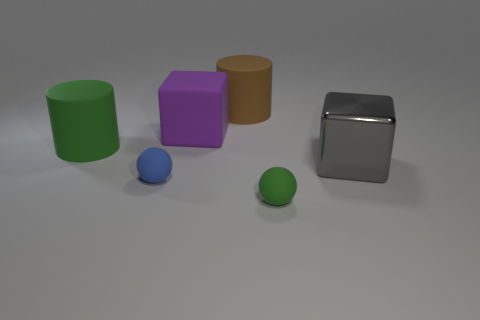What number of matte things are either large green cylinders or green balls?
Ensure brevity in your answer.  2. The shiny object is what size?
Provide a short and direct response. Large. What number of objects are either big green cubes or big purple blocks that are behind the large gray metallic object?
Give a very brief answer. 1. What number of other objects are the same color as the big rubber cube?
Ensure brevity in your answer.  0. There is a gray block; is it the same size as the matte sphere that is left of the brown cylinder?
Your response must be concise. No. There is a green thing right of the purple cube; is it the same size as the brown matte thing?
Your answer should be compact. No. What number of other things are made of the same material as the big purple cube?
Keep it short and to the point. 4. Are there an equal number of large purple rubber things that are on the right side of the tiny green sphere and big cylinders that are on the right side of the tiny blue thing?
Keep it short and to the point. No. What is the color of the block that is on the left side of the big block that is on the right side of the purple matte cube left of the tiny green matte ball?
Offer a terse response. Purple. What is the shape of the green matte object on the left side of the big brown cylinder?
Offer a very short reply. Cylinder. 